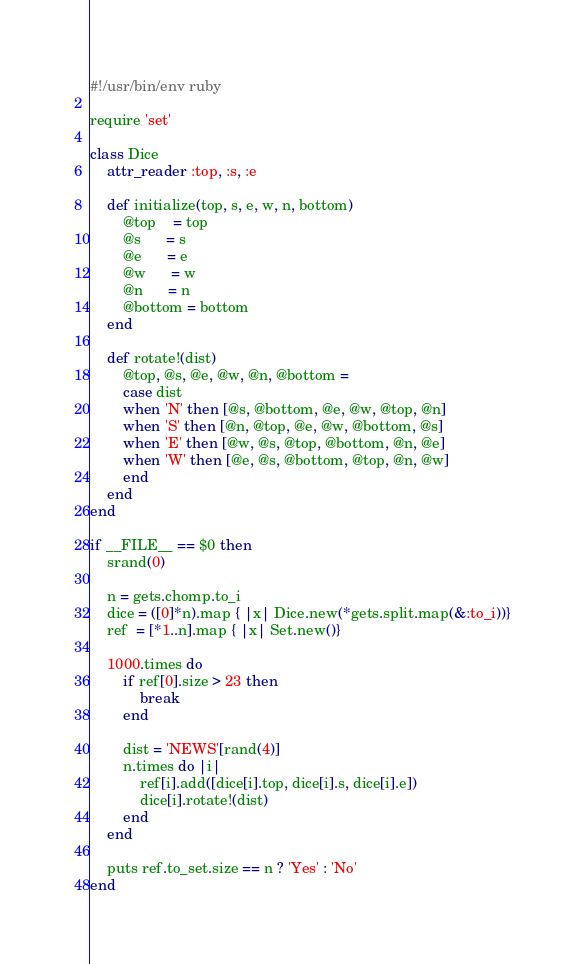Convert code to text. <code><loc_0><loc_0><loc_500><loc_500><_Ruby_>#!/usr/bin/env ruby

require 'set'

class Dice
	attr_reader :top, :s, :e

    def initialize(top, s, e, w, n, bottom)
        @top    = top
        @s      = s
        @e      = e
        @w      = w
        @n      = n
        @bottom = bottom
	end

	def rotate!(dist)
		@top, @s, @e, @w, @n, @bottom = 
		case dist
		when 'N' then [@s, @bottom, @e, @w, @top, @n]
		when 'S' then [@n, @top, @e, @w, @bottom, @s]
		when 'E' then [@w, @s, @top, @bottom, @n, @e]
		when 'W' then [@e, @s, @bottom, @top, @n, @w]
		end
	end
end

if __FILE__ == $0 then
	srand(0)

	n = gets.chomp.to_i
	dice = ([0]*n).map { |x| Dice.new(*gets.split.map(&:to_i))}
	ref  = [*1..n].map { |x| Set.new()}

	1000.times do
		if ref[0].size > 23 then
			break
		end

		dist = 'NEWS'[rand(4)]
		n.times do |i|
			ref[i].add([dice[i].top, dice[i].s, dice[i].e])
			dice[i].rotate!(dist)
		end
	end

	puts ref.to_set.size == n ? 'Yes' : 'No'
end

</code> 